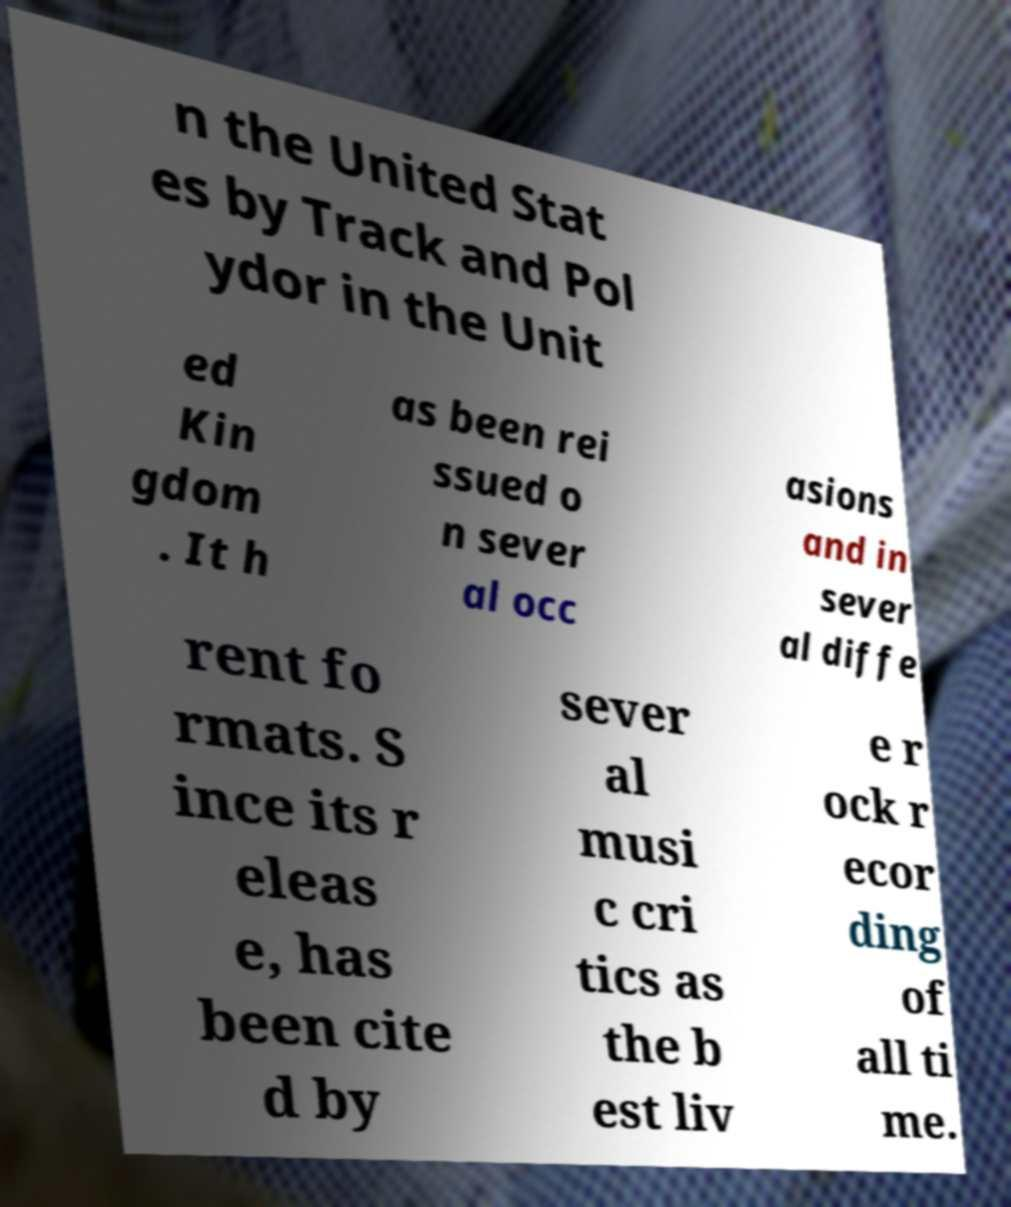Please read and relay the text visible in this image. What does it say? n the United Stat es by Track and Pol ydor in the Unit ed Kin gdom . It h as been rei ssued o n sever al occ asions and in sever al diffe rent fo rmats. S ince its r eleas e, has been cite d by sever al musi c cri tics as the b est liv e r ock r ecor ding of all ti me. 